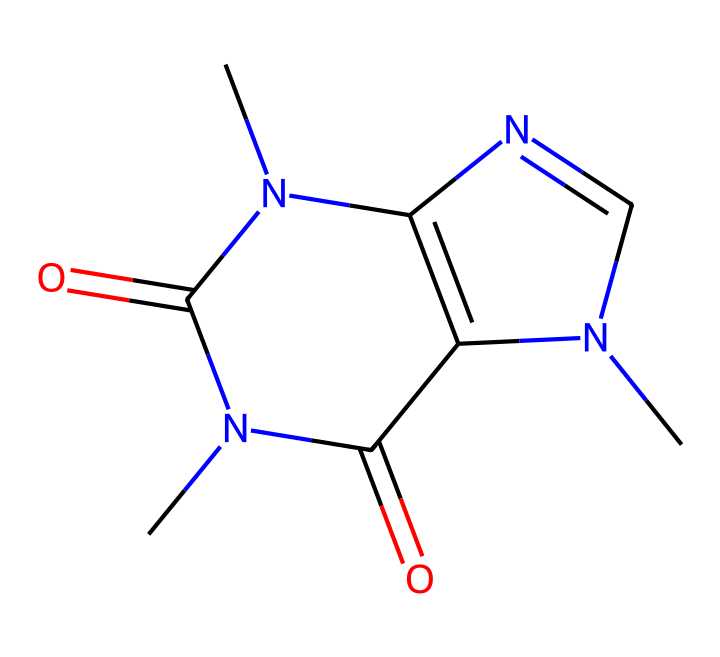What is the molecular formula of caffeine from its SMILES representation? To determine the molecular formula, we need to count the number of each type of atom represented in the SMILES. The structure contains 8 carbon (C), 10 hydrogen (H), 4 nitrogen (N), and 2 oxygen (O) atoms. Thus, the molecular formula is C8H10N4O2.
Answer: C8H10N4O2 How many nitrogen atoms are present in this caffeine structure? Analyzing the SMILES, we can identify the nitrogen atoms symbolized by "N". Counting these reveals that there are 4 nitrogen atoms in the structure.
Answer: 4 What type of compound does caffeine belong to based on its structure? Caffeine's structure features nitrogen heterocycles, which categorizes it as an alkaloid. Alkaloids are typically derived from plant sources and known for their pharmacological effects.
Answer: alkaloid How many rings are present in the caffeine molecule? By examining the SMILES, we find indications of cyclic structures through numerical markers '1' and '2', showing us that there are two interconnected rings present in the caffeine molecule.
Answer: 2 What is the significance of the nitrogen atoms in caffeine? The nitrogen atoms in caffeine contribute to its basicity and ability to act as a stimulant. Their placement within the heterocyclic rings supports the molecule's function in inhibiting adenosine receptors in the brain, which promotes alertness.
Answer: stimulant What is a major physiological effect of caffeine when consumed? When ingested, caffeine primarily acts as a stimulant that increases alertness and reduces fatigue. This is due to its interaction with the central nervous system, where it blocks adenosine receptors.
Answer: increased alertness How many oxygen atoms does caffeine have? Simply visualizing the SMILES, we can see atomic symbols "O" present twice within the structure. So, there are 2 oxygen atoms in the caffeine molecule.
Answer: 2 